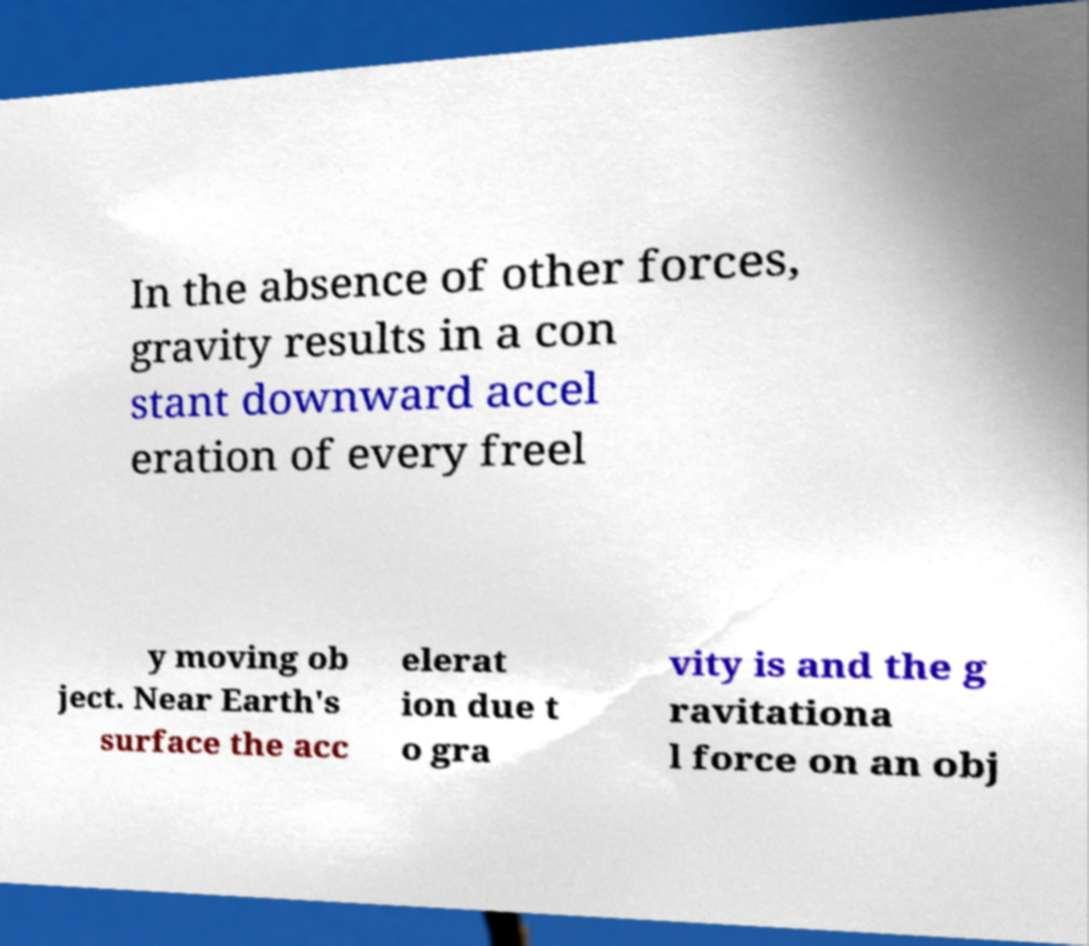Please identify and transcribe the text found in this image. In the absence of other forces, gravity results in a con stant downward accel eration of every freel y moving ob ject. Near Earth's surface the acc elerat ion due t o gra vity is and the g ravitationa l force on an obj 